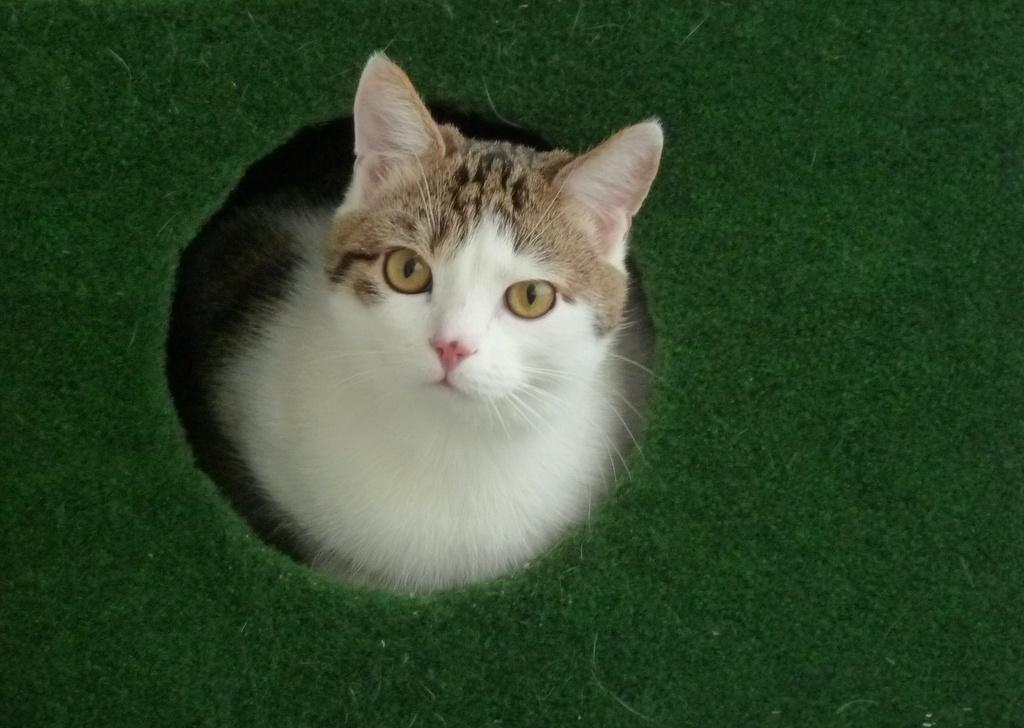What color is the sheet in the image? The sheet in the image is green. What type of animal is on the green sheet? There is a white cat on the green sheet. What color are the cat's eyes? The cat has brown eyes. What time of day is it in the image, considering the presence of the afternoon? The provided facts do not mention the time of day or the presence of the afternoon, so it cannot be determined from the image. 